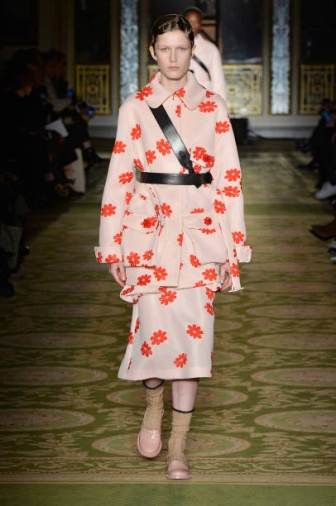Imagine the model is in a different time period. How would this fashion look stand out? Transporting this fashion look to a different time period, such as the Victorian era, would create a fascinating contrast. The vibrant colors and bold patterns would starkly differ from the muted tones and intricate lace details typically associated with Victorian fashion. The modern cut and silhouette of the dress, paired with the unconventional accessories like pink socks and beige heels, would stand out as avant-garde and rebellious.

In a society known for its strict fashion codes and modesty, this outfit would likely cause quite a stir, challenging conventional norms and sparking debates about the future of fashion and individual expression. The model would be seen as a trailblazer, pushing the boundaries of what is considered acceptable and paving the way for future generations to embrace creativity and innovation in their attire.  Tell a whimsical story where the model embarks on an adventure after the fashion show. After the fashion show, the model finds herself surrounded by adoring fans and photographers. But amid the flurry of excitement, she notices a mysterious, shimmering door at the far end of the room. Intrigued, she approaches and finds herself transported to a fantastical world where the colors are more vibrant, and the air is filled with the scent of blooming flowers.

In this magical realm, every outfit holds a secret power. The pink dress with red flowers she’s wearing allows her to communicate with the flora around her. The flowers guide her through lush forests and across sparkling rivers, leading her to a hidden village in need of her help. The black sash around her waist grants her incredible strength, while the quirky pink socks give her the ability to traverse treacherous terrains without faltering.

The villagers reveal that their land has been cursed by an envious sorceress who cannot create beauty and thus seeks to destroy it. With her newfound powers, the model sets off on a quest to find the sorceress and break the curse. Along the way, she encounters whimsical creatures, faces challenges that test her ingenuity, and learns the true power of her unique fashion sense.

In the end, she confronts the sorceress not with hostility but with compassion, showing her the beauty she possesses within. The curse is lifted, and the village returns to its former splendor. The model returns to the real world, forever changed, bringing a touch of magic and a story of adventure to every runway she graces. 